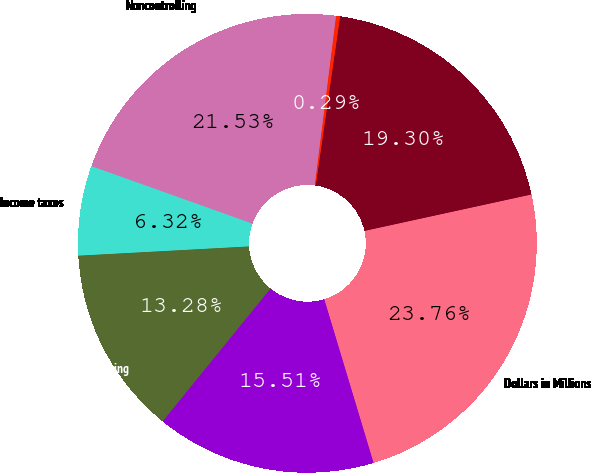Convert chart. <chart><loc_0><loc_0><loc_500><loc_500><pie_chart><fcel>Dollars in Millions<fcel>sanofi partnerships<fcel>Other<fcel>Noncontrolling<fcel>Income taxes<fcel>Net earnings from continuing<fcel>Net earnings attributable to<nl><fcel>23.76%<fcel>19.3%<fcel>0.29%<fcel>21.53%<fcel>6.32%<fcel>13.28%<fcel>15.51%<nl></chart> 